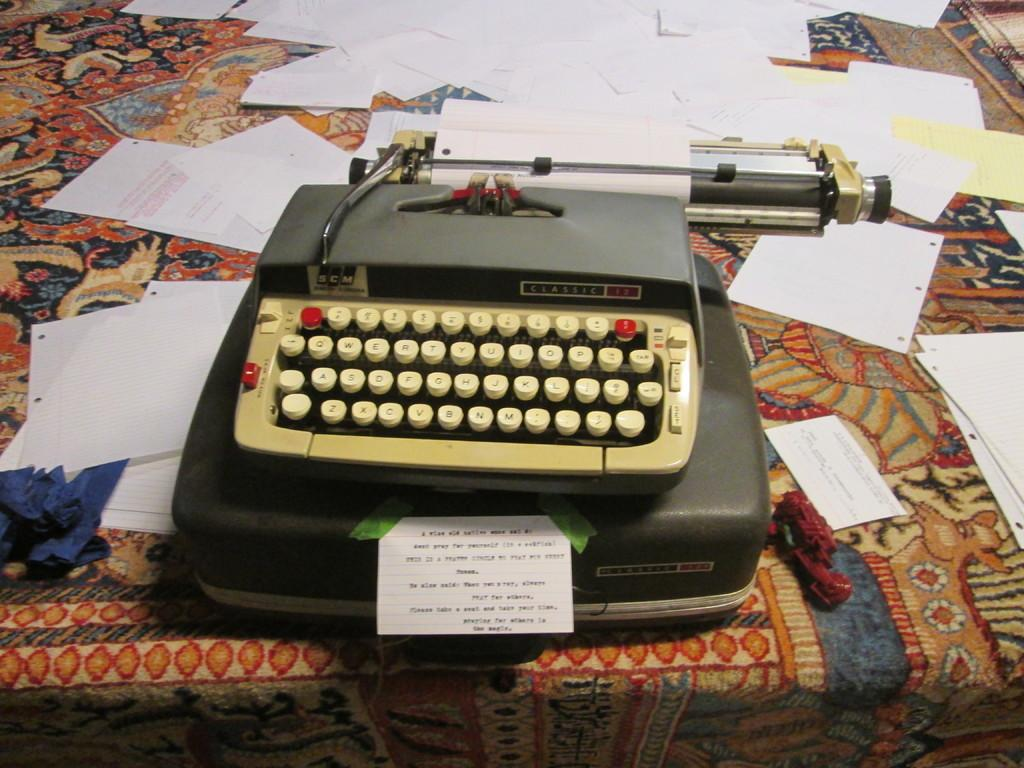<image>
Render a clear and concise summary of the photo. An antique SCM Classic typewriter with papers scattered about it. 